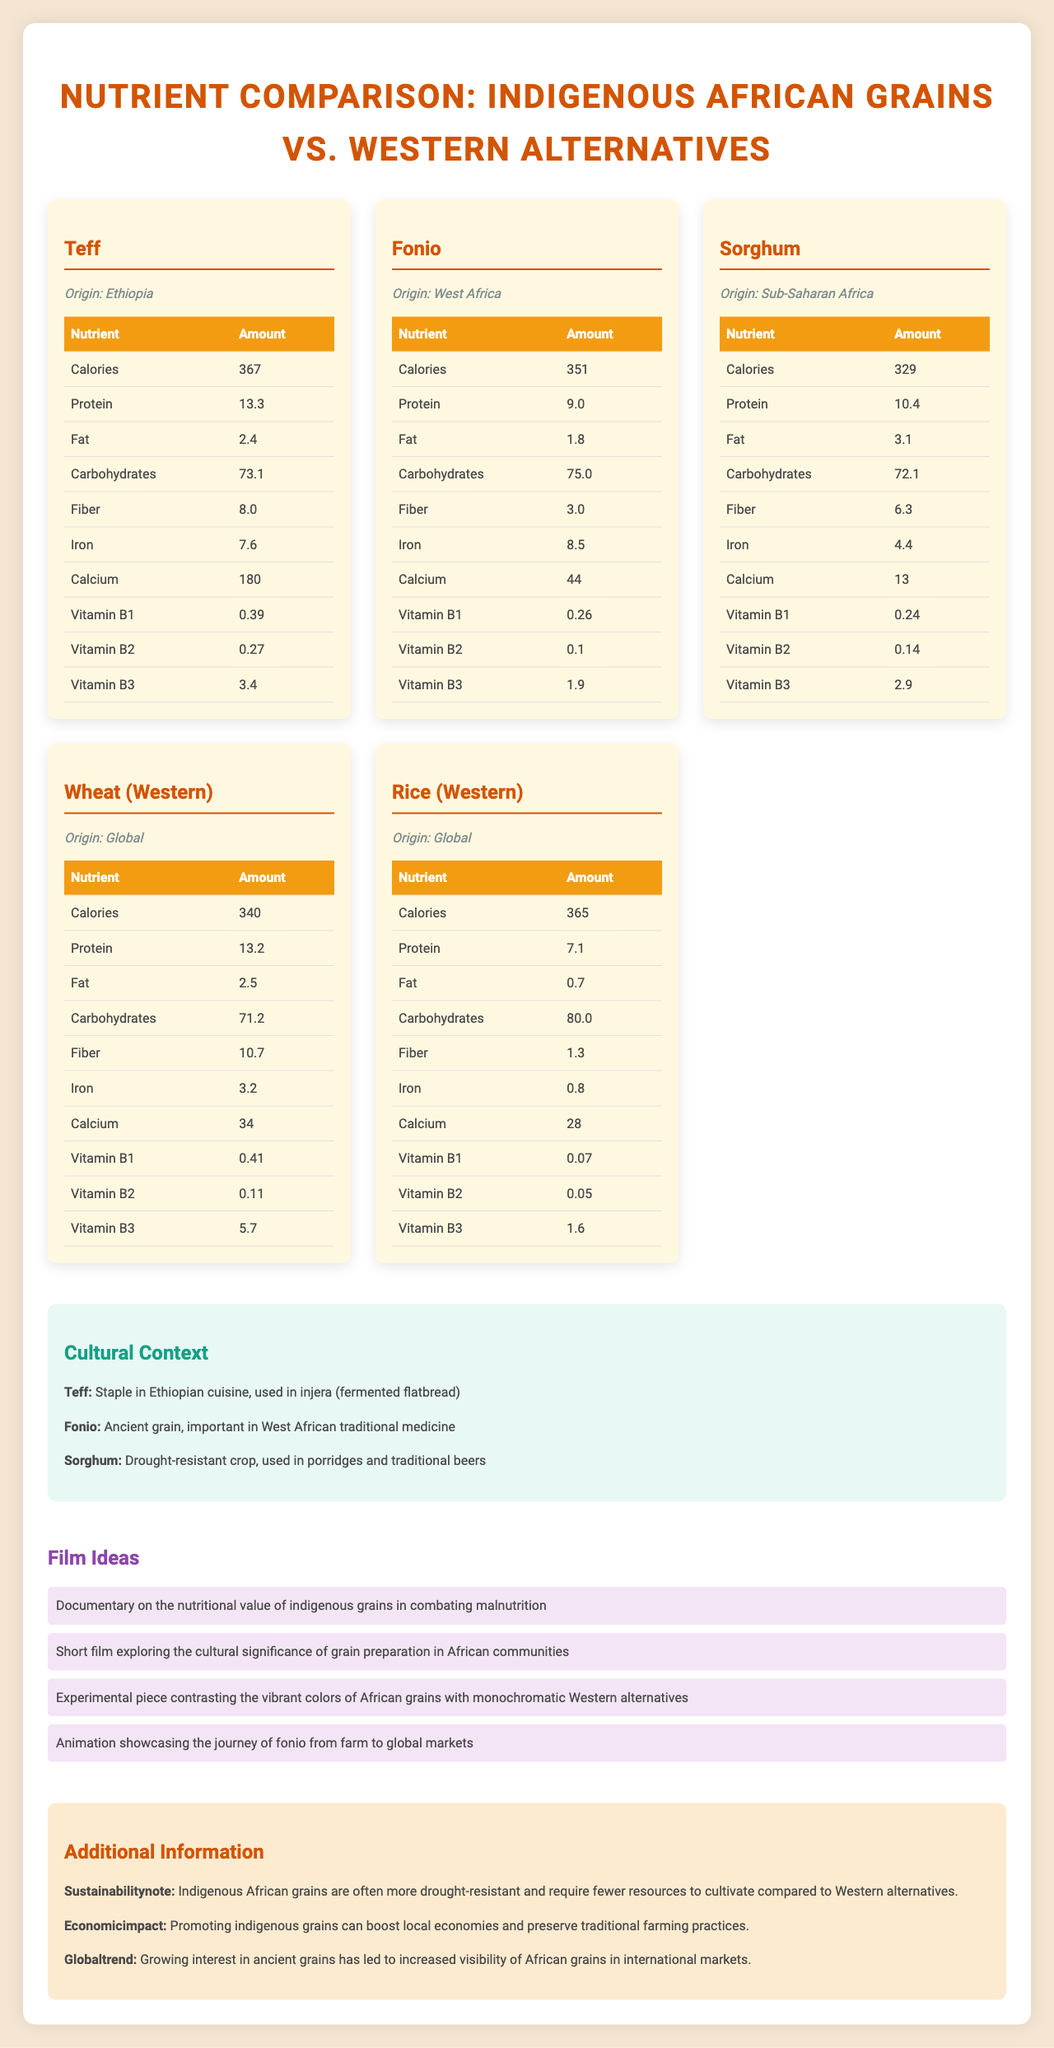what is the origin of Teff? Teff is clearly listed as originating from Ethiopia in the document.
Answer: Ethiopia how many calories are in 100g of Fonio? The nutrient table for Fonio lists the calories as 351 per 100g serving size.
Answer: 351 between Sorghum and Wheat, which grain has more fiber? Sorghum has 6.3g of fiber per 100g, while Wheat has 10.7g, making Wheat the grain with more fiber.
Answer: Wheat what is the serving size for all grains listed in the document? The serving size for Teff, Fonio, Sorghum, Wheat, and Rice is mentioned as 100g.
Answer: 100g which grain has the highest amount of iron? Fonio is listed as containing 8.5mg of iron per 100g, which is higher than the other grains.
Answer: Fonio which grains are more drought-resistant? A. Teff, Fonio, Sorghum B. Wheat, Rice C. Sorghum, Wheat D. Rice, Fonio The additional information section mentions that indigenous African grains like Teff, Fonio, and Sorghum are more drought-resistant.
Answer: A which grain has the least amount of fat? 1. Teff 2. Wheat 3. Sorghum 4. Rice Rice has only 0.7g of fat per 100g, which is the least among the listed grains.
Answer: 4 is Fonio more commonly used in traditional medicine than the other grains? The cultural context reveals that Fonio is particularly important in West African traditional medicine.
Answer: Yes describe the main idea of the document The document aims to highlight the nutritional benefits and cultural context of African grains compared to Western alternatives, providing detailed nutrient information and incorporating cultural and sustainability aspects.
Answer: The document is a nutritional comparison chart between indigenous African grains (Teff, Fonio, Sorghum) and Western alternatives (Wheat, Rice). It includes detailed nutrient profiles, cultural significance, suggestions for film ideas, and additional information on sustainability and economic impact. how long does it take to cultivate Teff? The document provides extensive nutritional and cultural context but does not specify the cultivation duration of Teff.
Answer: Not enough information which grain is significant in Ethiopian cuisine? According to the cultural context, Teff is a staple in Ethiopian cuisine and is used in the making of injera (fermented flatbread).
Answer: Teff which grain among the listed has the highest protein content? The nutrient section shows that Teff contains 13.3g of protein per 100g, the highest among the grains listed.
Answer: Teff how many film ideas are provided in the document? The film ideas section of the document lists a total of four unique film ideas.
Answer: 4 which vitamin is in the highest amount in Wheat? A. Vitamin B1 B. Vitamin B2 C. Vitamin B3 D. Vitamin C Wheat contains 5.7mg of Vitamin B3 per 100g, which is the highest amount among the listed vitamins for Wheat.
Answer: C what is a global trend regarding ancient grains? The additional information section mentions that there is a growing interest in ancient grains, contributing to the increased visibility of African grains globally.
Answer: Growing interest in ancient grains has led to increased visibility of African grains in international markets. 